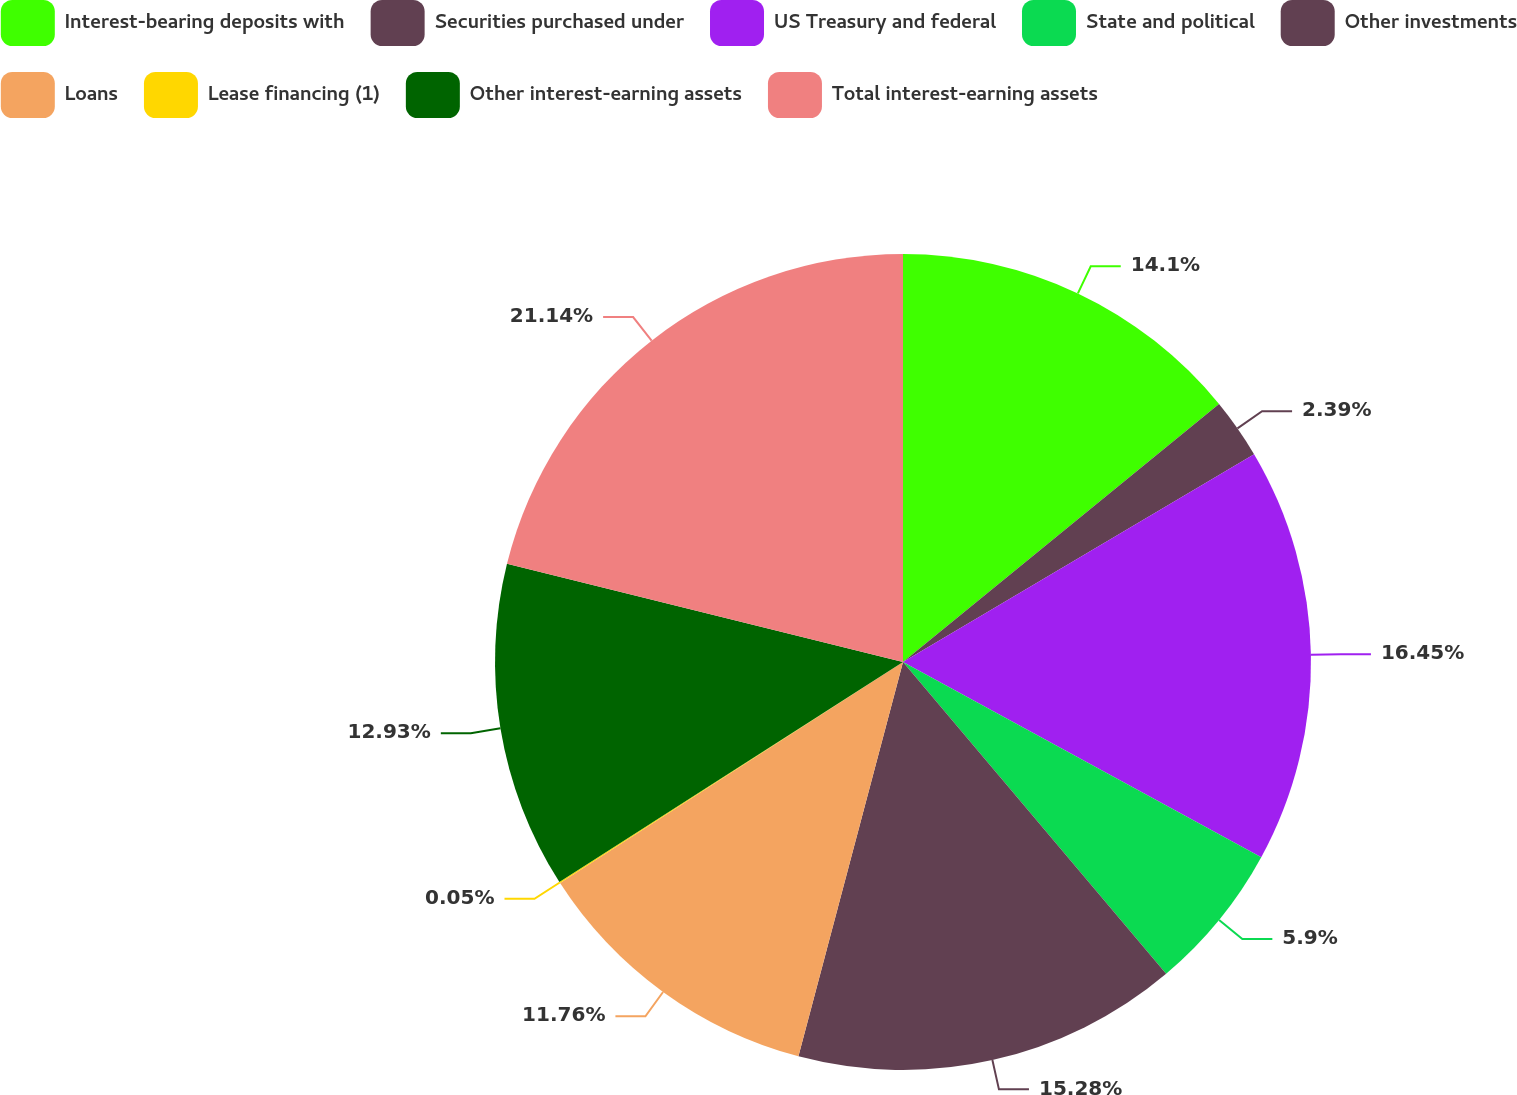Convert chart to OTSL. <chart><loc_0><loc_0><loc_500><loc_500><pie_chart><fcel>Interest-bearing deposits with<fcel>Securities purchased under<fcel>US Treasury and federal<fcel>State and political<fcel>Other investments<fcel>Loans<fcel>Lease financing (1)<fcel>Other interest-earning assets<fcel>Total interest-earning assets<nl><fcel>14.1%<fcel>2.39%<fcel>16.45%<fcel>5.9%<fcel>15.28%<fcel>11.76%<fcel>0.05%<fcel>12.93%<fcel>21.13%<nl></chart> 